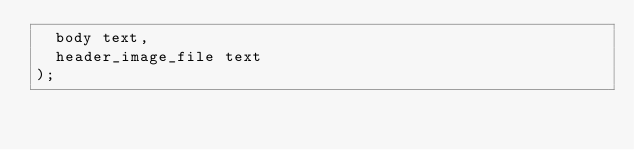<code> <loc_0><loc_0><loc_500><loc_500><_SQL_>  body text,
  header_image_file text
);</code> 